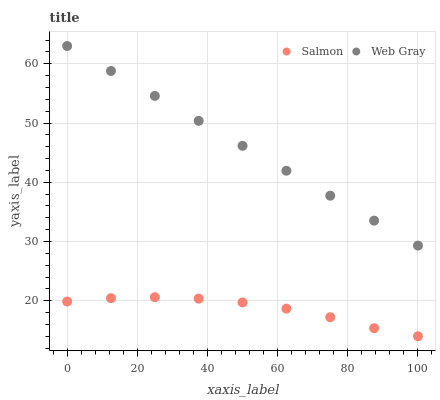Does Salmon have the minimum area under the curve?
Answer yes or no. Yes. Does Web Gray have the maximum area under the curve?
Answer yes or no. Yes. Does Salmon have the maximum area under the curve?
Answer yes or no. No. Is Web Gray the smoothest?
Answer yes or no. Yes. Is Salmon the roughest?
Answer yes or no. Yes. Is Salmon the smoothest?
Answer yes or no. No. Does Salmon have the lowest value?
Answer yes or no. Yes. Does Web Gray have the highest value?
Answer yes or no. Yes. Does Salmon have the highest value?
Answer yes or no. No. Is Salmon less than Web Gray?
Answer yes or no. Yes. Is Web Gray greater than Salmon?
Answer yes or no. Yes. Does Salmon intersect Web Gray?
Answer yes or no. No. 